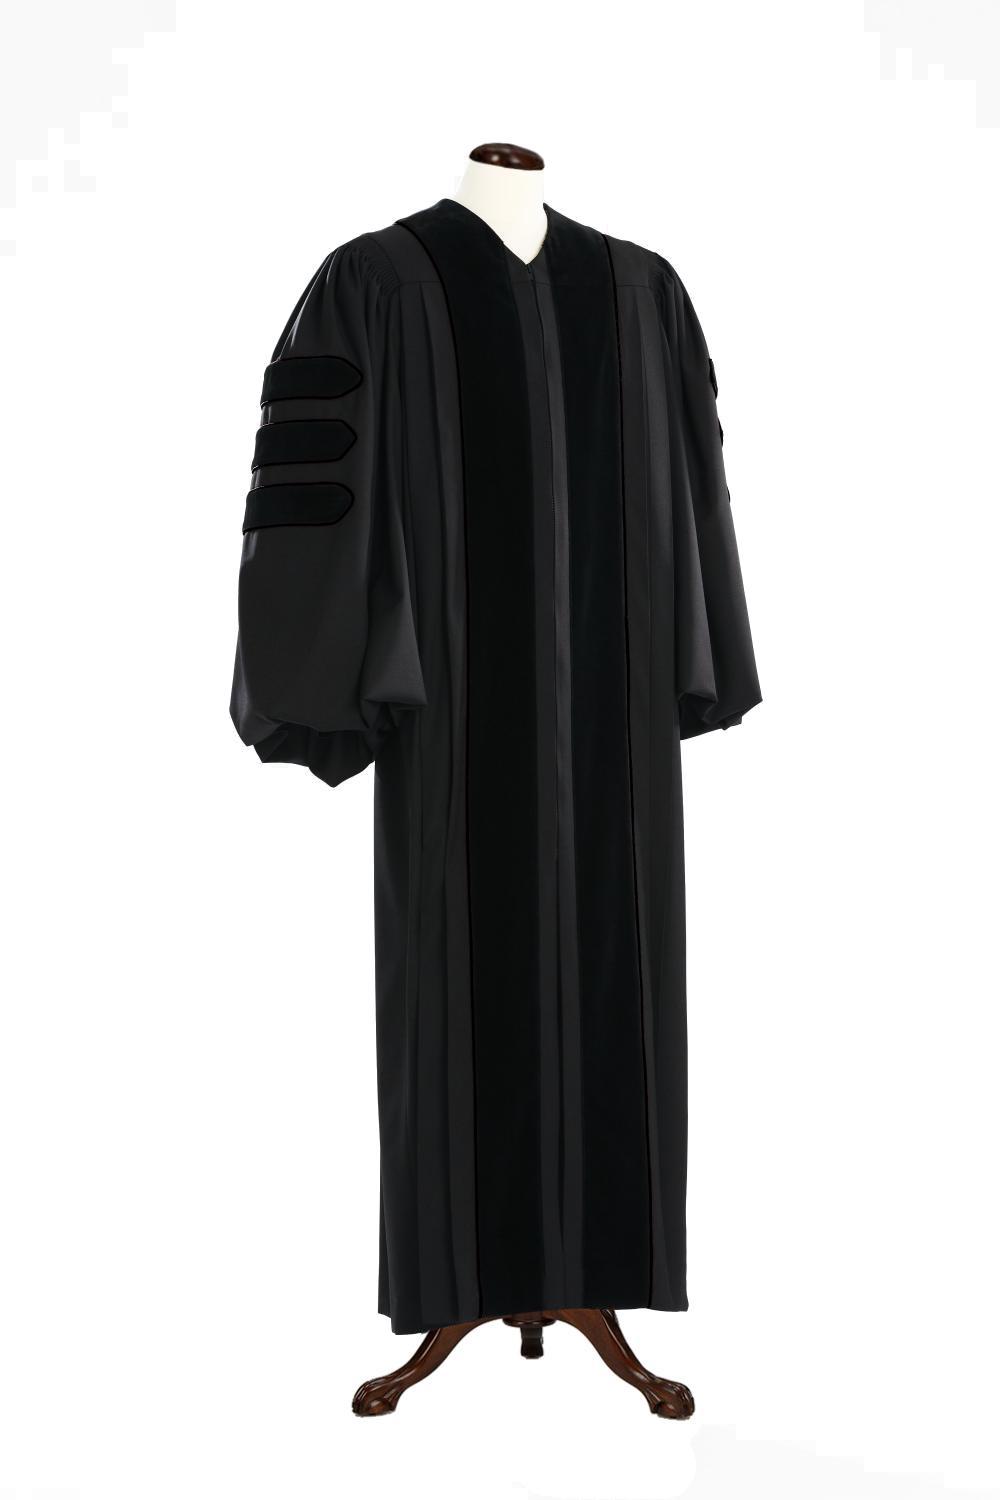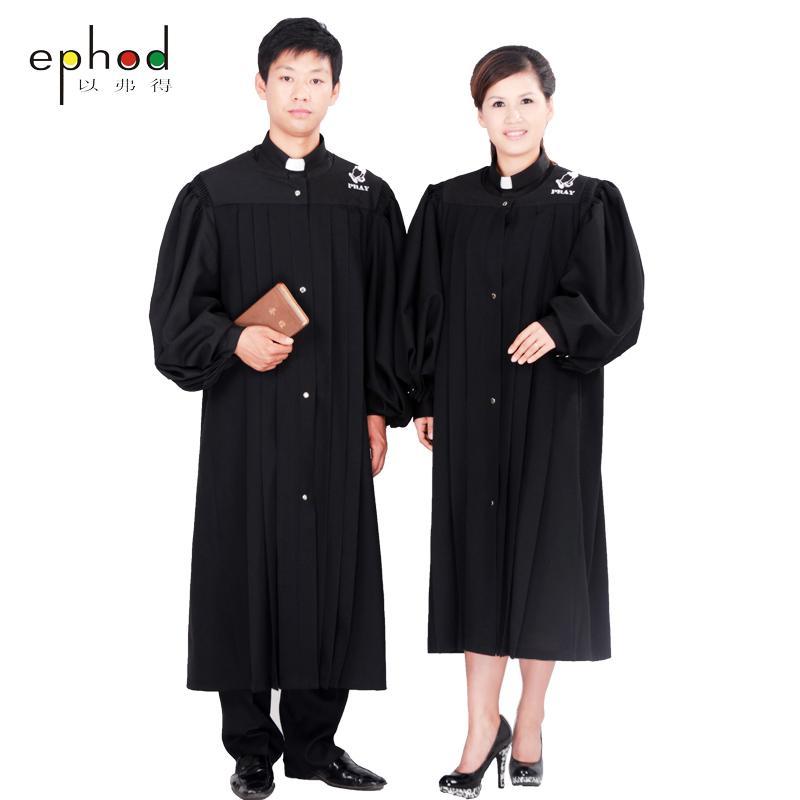The first image is the image on the left, the second image is the image on the right. Examine the images to the left and right. Is the description "At least one image shows predominantly black gown modeled by a human." accurate? Answer yes or no. Yes. The first image is the image on the left, the second image is the image on the right. For the images displayed, is the sentence "No graduation attire is modeled by a human, and at least one graduation robe is on a headless mannequin form." factually correct? Answer yes or no. No. 